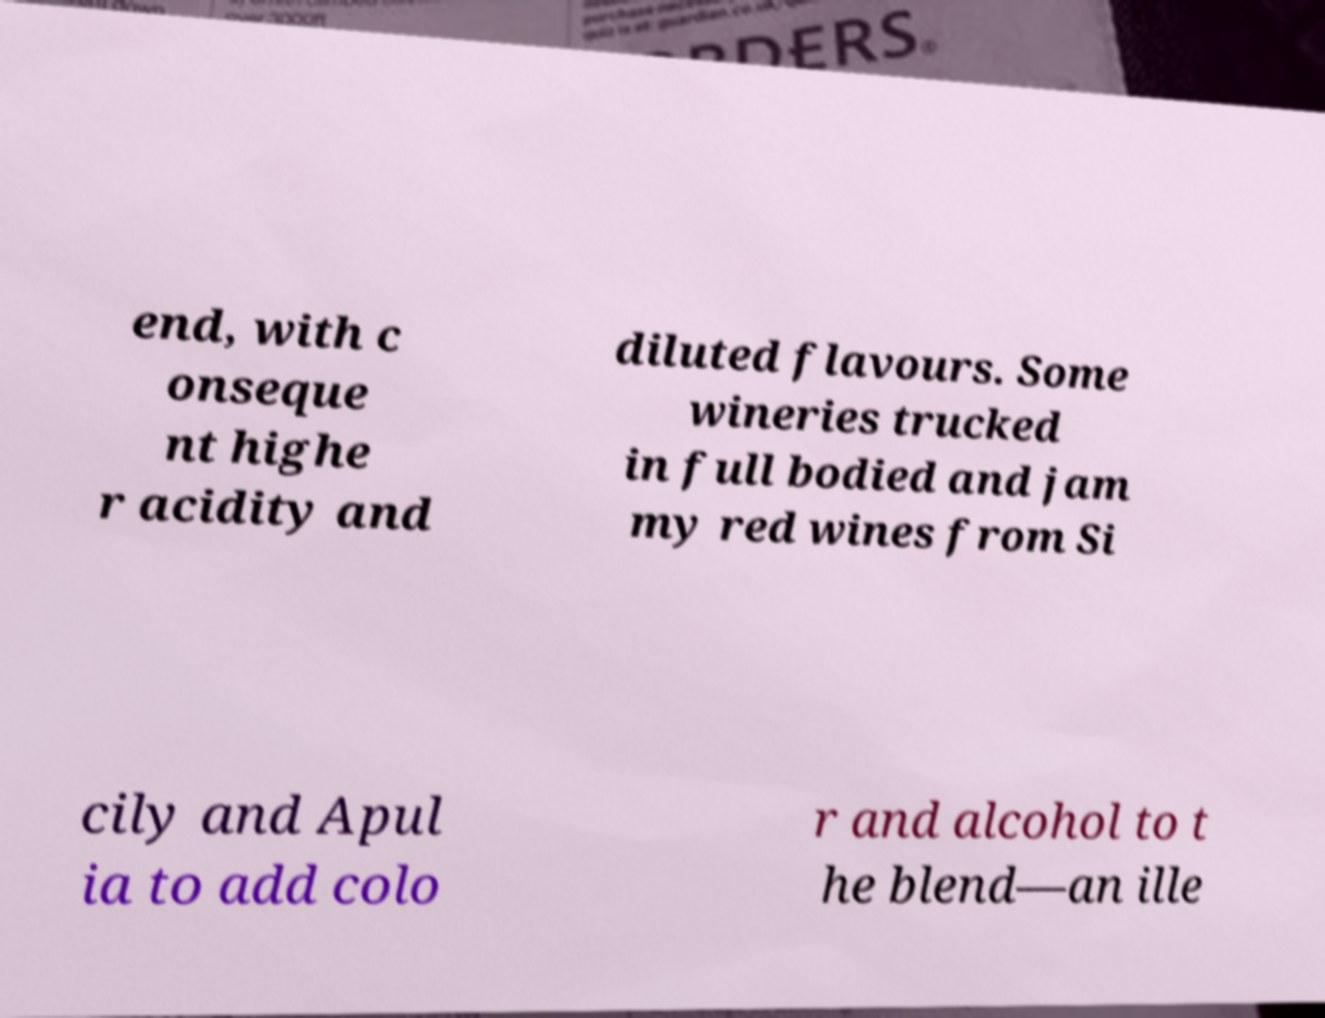Could you extract and type out the text from this image? end, with c onseque nt highe r acidity and diluted flavours. Some wineries trucked in full bodied and jam my red wines from Si cily and Apul ia to add colo r and alcohol to t he blend—an ille 